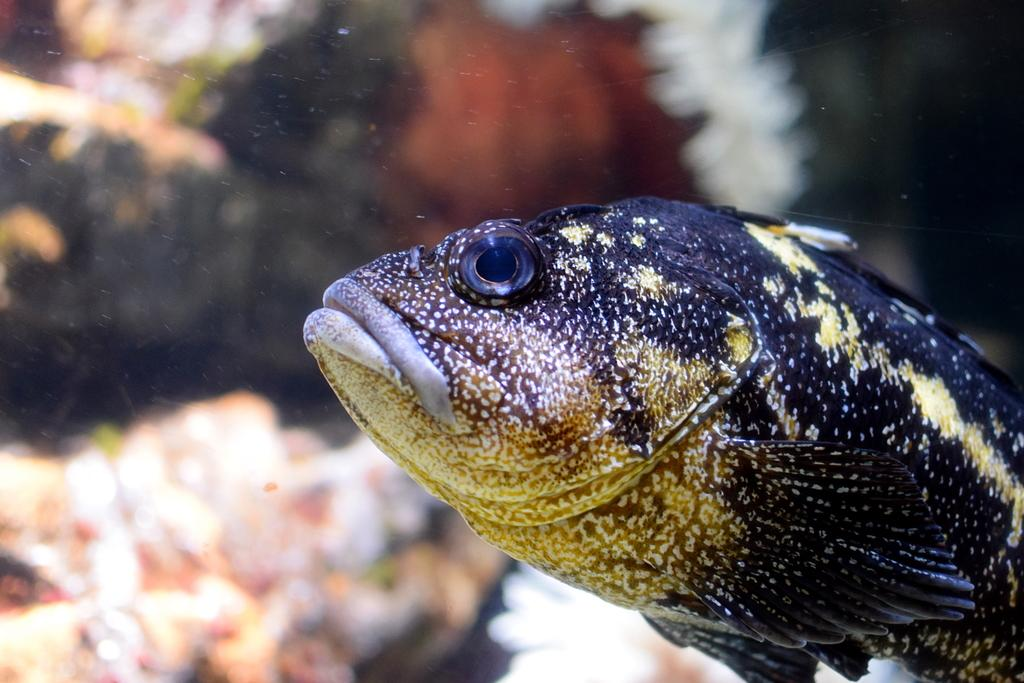What is the main subject of the image? There is a fish in the image. Can you describe the background of the image? The background of the image is blurry. What type of skate is the aunt using in the image? There is no aunt or skate present in the image; it features a fish and a blurry background. How many eyes does the fish have in the image? The number of eyes the fish has cannot be determined from the image, as the fish is not shown in a way that clearly displays its eyes. 